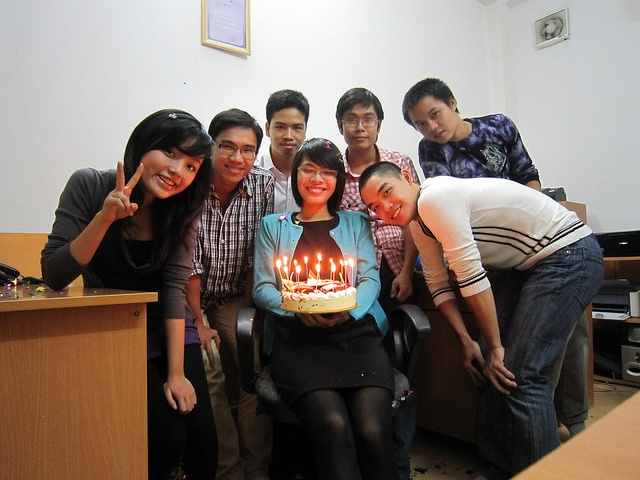Describe the objects in this image and their specific colors. I can see people in lightgray, black, gray, and maroon tones, people in lightgray, black, teal, maroon, and darkgray tones, people in lightgray, black, brown, and maroon tones, people in lightgray, black, maroon, and gray tones, and people in lightgray, black, and gray tones in this image. 